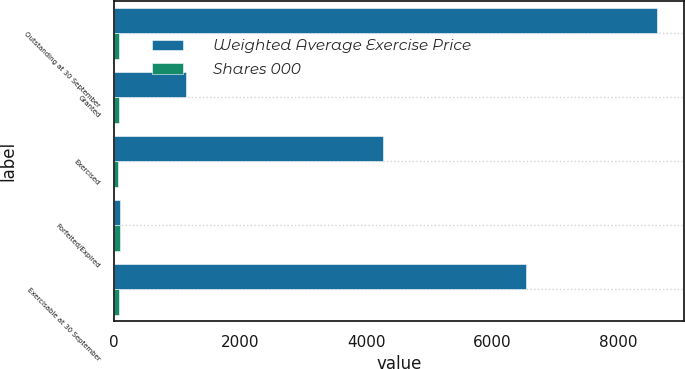Convert chart to OTSL. <chart><loc_0><loc_0><loc_500><loc_500><stacked_bar_chart><ecel><fcel>Outstanding at 30 September<fcel>Granted<fcel>Exercised<fcel>Forfeited/Expired<fcel>Exercisable at 30 September<nl><fcel>Weighted Average Exercise Price<fcel>8612<fcel>1140<fcel>4263<fcel>100<fcel>6531<nl><fcel>Shares 000<fcel>75.69<fcel>81.76<fcel>55.17<fcel>85.37<fcel>73.23<nl></chart> 